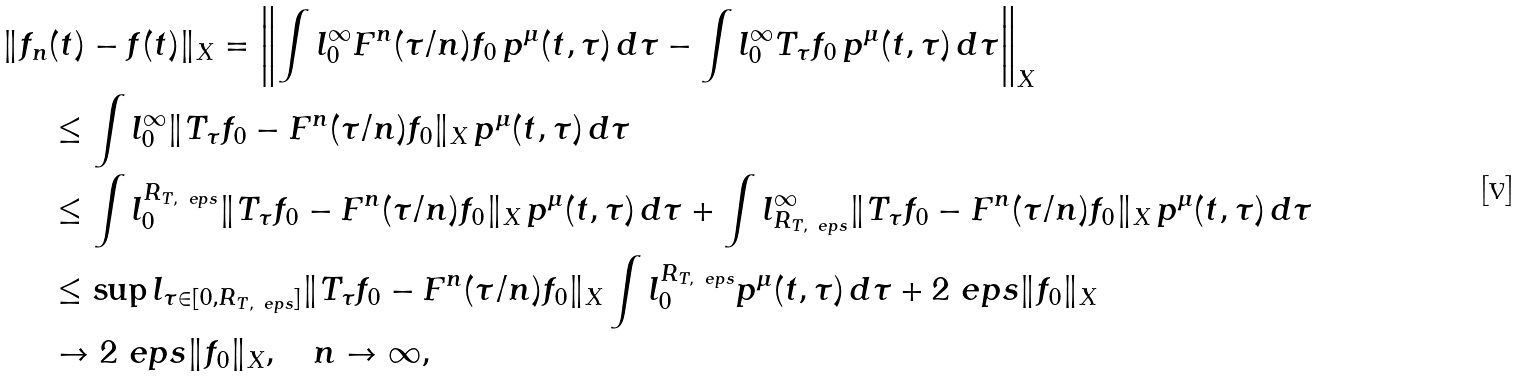<formula> <loc_0><loc_0><loc_500><loc_500>\| f _ { n } & ( t ) - f ( t ) \| _ { X } = \left \| \int l _ { 0 } ^ { \infty } F ^ { n } ( \tau / n ) f _ { 0 } \, p ^ { \mu } ( t , \tau ) \, d \tau - \int l _ { 0 } ^ { \infty } T _ { \tau } f _ { 0 } \, p ^ { \mu } ( t , \tau ) \, d \tau \right \| _ { X } \\ & \leq \int l _ { 0 } ^ { \infty } \| T _ { \tau } f _ { 0 } - F ^ { n } ( \tau / n ) f _ { 0 } \| _ { X } \, p ^ { \mu } ( t , \tau ) \, d \tau \\ & \leq \int l _ { 0 } ^ { R _ { T , \ e p s } } \| T _ { \tau } f _ { 0 } - F ^ { n } ( \tau / n ) f _ { 0 } \| _ { X } \, p ^ { \mu } ( t , \tau ) \, d \tau + \int l _ { R _ { T , \ e p s } } ^ { \infty } \| T _ { \tau } f _ { 0 } - F ^ { n } ( \tau / n ) f _ { 0 } \| _ { X } \, p ^ { \mu } ( t , \tau ) \, d \tau \\ & \leq \sup l _ { \tau \in [ 0 , R _ { T , \ e p s } ] } \| T _ { \tau } f _ { 0 } - F ^ { n } ( \tau / n ) f _ { 0 } \| _ { X } \int l _ { 0 } ^ { R _ { T , \ e p s } } p ^ { \mu } ( t , \tau ) \, d \tau + 2 \ e p s \| f _ { 0 } \| _ { X } \\ & \to 2 \ e p s \| f _ { 0 } \| _ { X } , \quad n \to \infty ,</formula> 